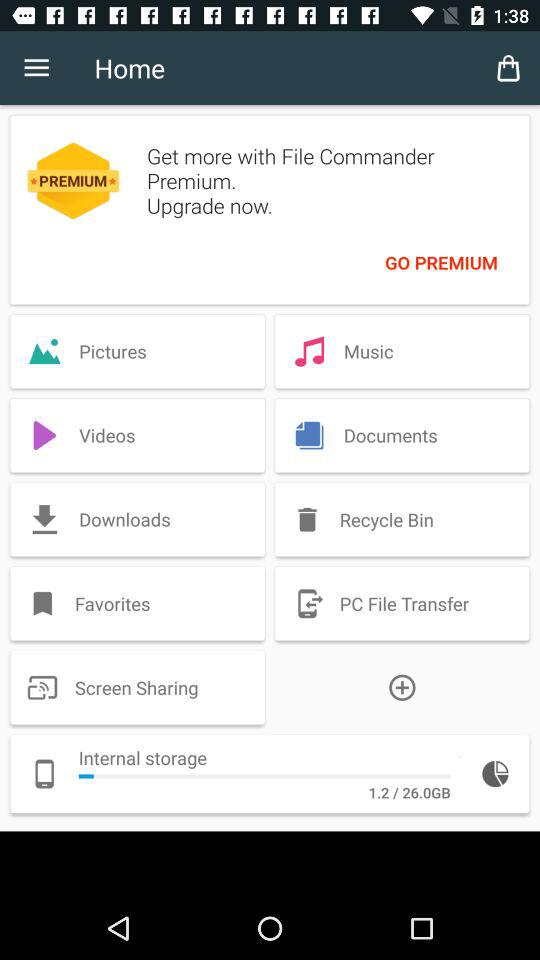How many more GB of storage are available than used?
Answer the question using a single word or phrase. 24.8 